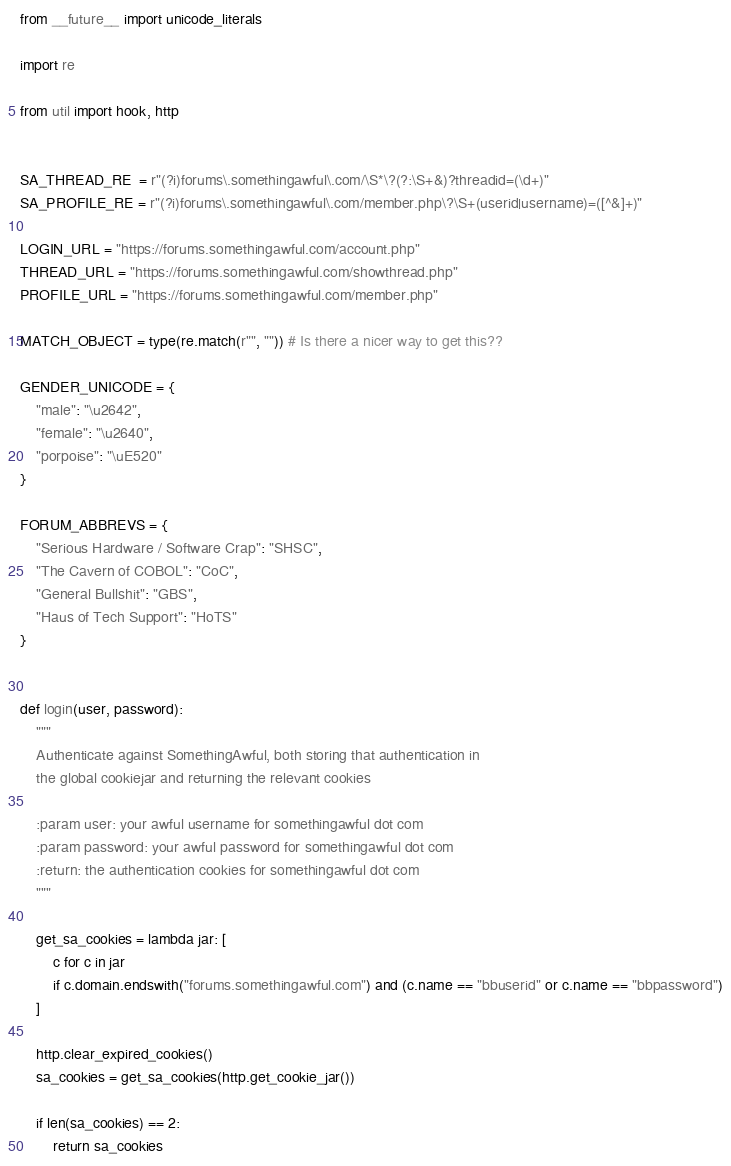Convert code to text. <code><loc_0><loc_0><loc_500><loc_500><_Python_>from __future__ import unicode_literals

import re

from util import hook, http


SA_THREAD_RE  = r"(?i)forums\.somethingawful\.com/\S*\?(?:\S+&)?threadid=(\d+)"
SA_PROFILE_RE = r"(?i)forums\.somethingawful\.com/member.php\?\S+(userid|username)=([^&]+)"

LOGIN_URL = "https://forums.somethingawful.com/account.php"
THREAD_URL = "https://forums.somethingawful.com/showthread.php"
PROFILE_URL = "https://forums.somethingawful.com/member.php"

MATCH_OBJECT = type(re.match(r"", "")) # Is there a nicer way to get this??

GENDER_UNICODE = {
    "male": "\u2642",
    "female": "\u2640",
    "porpoise": "\uE520"
}

FORUM_ABBREVS = {
    "Serious Hardware / Software Crap": "SHSC",
    "The Cavern of COBOL": "CoC",
    "General Bullshit": "GBS",
    "Haus of Tech Support": "HoTS"
}


def login(user, password):
    """
    Authenticate against SomethingAwful, both storing that authentication in
    the global cookiejar and returning the relevant cookies

    :param user: your awful username for somethingawful dot com
    :param password: your awful password for somethingawful dot com
    :return: the authentication cookies for somethingawful dot com
    """

    get_sa_cookies = lambda jar: [
        c for c in jar
        if c.domain.endswith("forums.somethingawful.com") and (c.name == "bbuserid" or c.name == "bbpassword")
    ]

    http.clear_expired_cookies()
    sa_cookies = get_sa_cookies(http.get_cookie_jar())

    if len(sa_cookies) == 2:
        return sa_cookies
</code> 